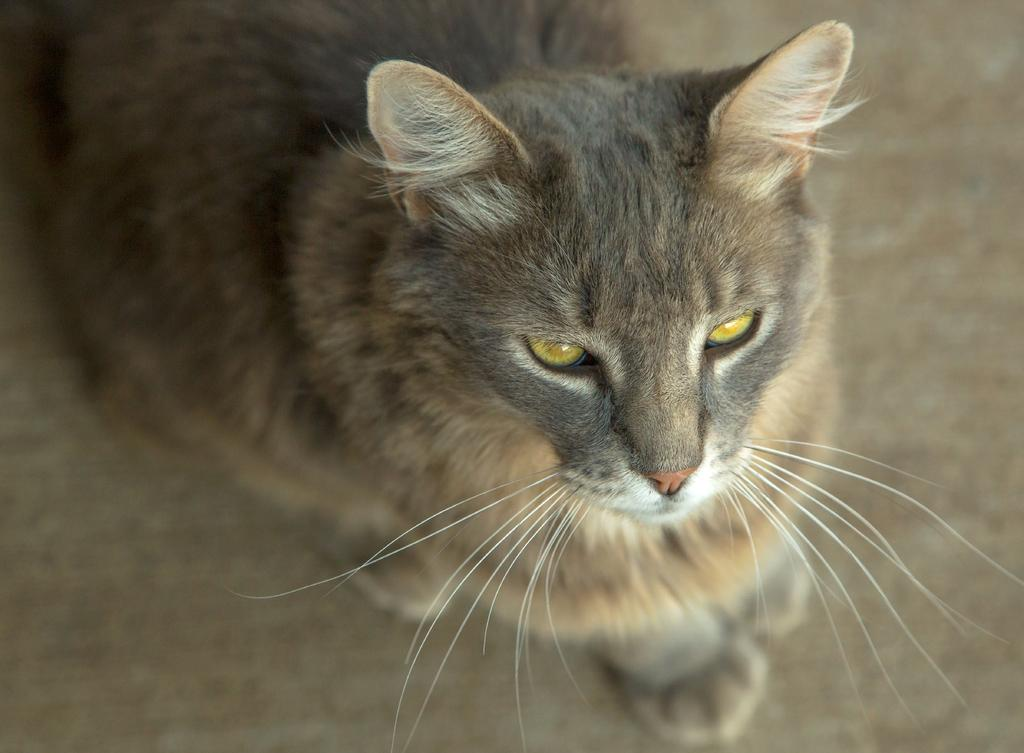What type of animal is in the image? There is a cat in the image. Where is the cat located in the image? The cat is sitting on a surface. What type of maid is visible in the image? There is no maid present in the image; it only features a cat sitting on a surface. 